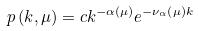Convert formula to latex. <formula><loc_0><loc_0><loc_500><loc_500>p \left ( k , \mu \right ) = c k ^ { - \alpha \left ( \mu \right ) } e ^ { - \nu _ { \alpha } \left ( \mu \right ) k }</formula> 